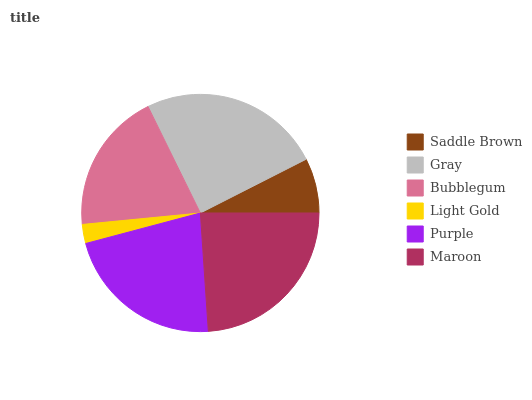Is Light Gold the minimum?
Answer yes or no. Yes. Is Gray the maximum?
Answer yes or no. Yes. Is Bubblegum the minimum?
Answer yes or no. No. Is Bubblegum the maximum?
Answer yes or no. No. Is Gray greater than Bubblegum?
Answer yes or no. Yes. Is Bubblegum less than Gray?
Answer yes or no. Yes. Is Bubblegum greater than Gray?
Answer yes or no. No. Is Gray less than Bubblegum?
Answer yes or no. No. Is Purple the high median?
Answer yes or no. Yes. Is Bubblegum the low median?
Answer yes or no. Yes. Is Maroon the high median?
Answer yes or no. No. Is Saddle Brown the low median?
Answer yes or no. No. 